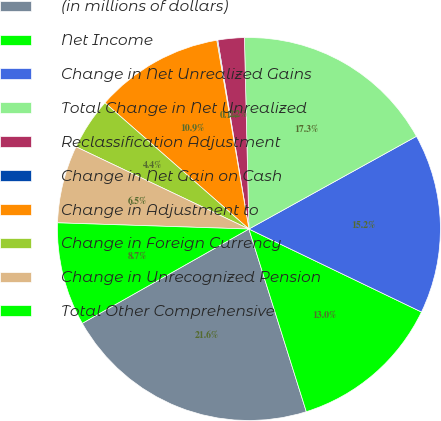<chart> <loc_0><loc_0><loc_500><loc_500><pie_chart><fcel>(in millions of dollars)<fcel>Net Income<fcel>Change in Net Unrealized Gains<fcel>Total Change in Net Unrealized<fcel>Reclassification Adjustment<fcel>Change in Net Gain on Cash<fcel>Change in Adjustment to<fcel>Change in Foreign Currency<fcel>Change in Unrecognized Pension<fcel>Total Other Comprehensive<nl><fcel>21.65%<fcel>13.02%<fcel>15.18%<fcel>17.33%<fcel>2.23%<fcel>0.08%<fcel>10.86%<fcel>4.39%<fcel>6.55%<fcel>8.71%<nl></chart> 